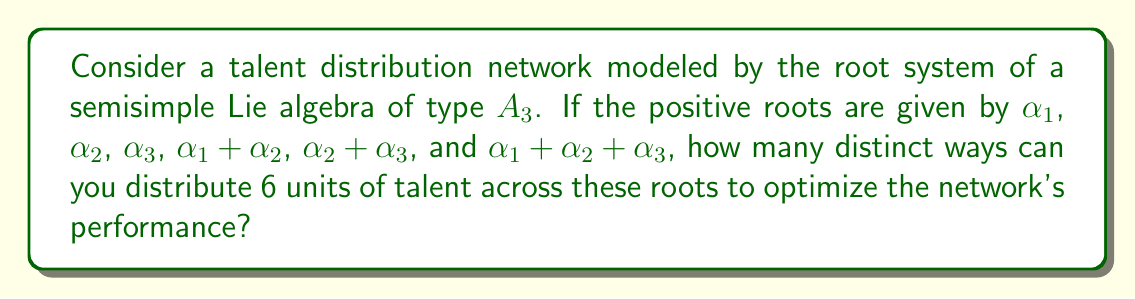Can you answer this question? To solve this problem, we need to understand the structure of the $A_3$ root system and apply combinatorial principles:

1) The $A_3$ root system corresponds to the Lie algebra $\mathfrak{sl}(4, \mathbb{C})$, which is often used in network theory.

2) We have 6 positive roots in total:
   $$\{\alpha_1, \alpha_2, \alpha_3, \alpha_1 + \alpha_2, \alpha_2 + \alpha_3, \alpha_1 + \alpha_2 + \alpha_3\}$$

3) We need to distribute 6 units of talent across these 6 roots. This is equivalent to finding the number of ways to place 6 indistinguishable objects into 6 distinct containers.

4) In combinatorial terms, this is a stars and bars problem. The formula for this is:

   $$\binom{n+k-1}{k-1}$$

   where $n$ is the number of objects (talent units) and $k$ is the number of containers (roots).

5) In our case, $n = 6$ and $k = 6$. So we need to calculate:

   $$\binom{6+6-1}{6-1} = \binom{11}{5}$$

6) We can calculate this using the formula:

   $$\binom{11}{5} = \frac{11!}{5!(11-5)!} = \frac{11!}{5!6!}$$

7) Expanding this:
   $$\frac{11 \times 10 \times 9 \times 8 \times 7}{5 \times 4 \times 3 \times 2 \times 1} = 462$$

Therefore, there are 462 distinct ways to distribute the talent across the root system.
Answer: 462 